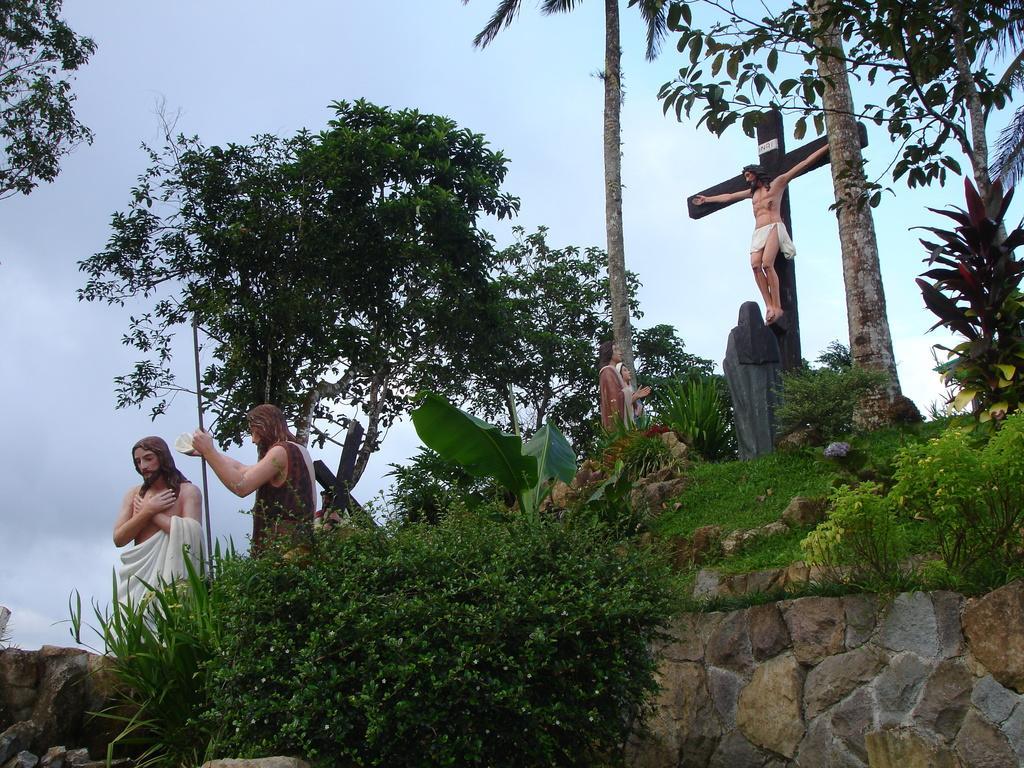Could you give a brief overview of what you see in this image? There is a greenery and in between the greenery there are few sculptures of Jesus and in the background there is a sky. 